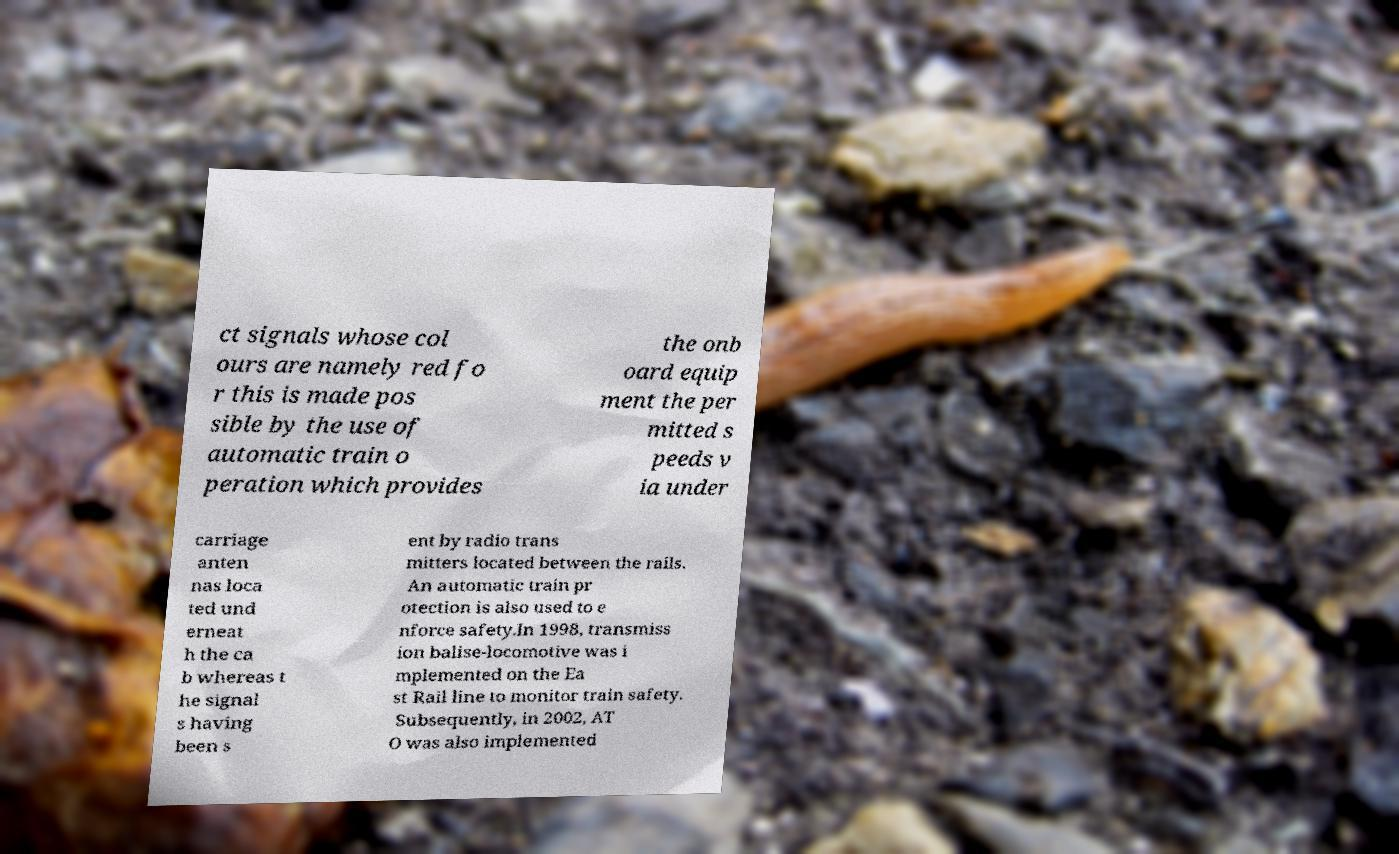Could you extract and type out the text from this image? ct signals whose col ours are namely red fo r this is made pos sible by the use of automatic train o peration which provides the onb oard equip ment the per mitted s peeds v ia under carriage anten nas loca ted und erneat h the ca b whereas t he signal s having been s ent by radio trans mitters located between the rails. An automatic train pr otection is also used to e nforce safety.In 1998, transmiss ion balise-locomotive was i mplemented on the Ea st Rail line to monitor train safety. Subsequently, in 2002, AT O was also implemented 